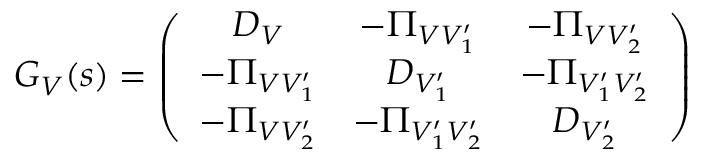Convert formula to latex. <formula><loc_0><loc_0><loc_500><loc_500>G _ { V } ( s ) = \left ( \begin{array} { c c c } { { D _ { V } } } & { { - \Pi _ { V V _ { 1 } ^ { \prime } } } } & { { - \Pi _ { V V _ { 2 } ^ { \prime } } } } \\ { { - \Pi _ { V V _ { 1 } ^ { \prime } } } } & { { D _ { V _ { 1 } ^ { \prime } } } } & { { - \Pi _ { V _ { 1 } ^ { \prime } V _ { 2 } ^ { \prime } } } } \\ { { - \Pi _ { V V _ { 2 } ^ { \prime } } } } & { { - \Pi _ { V _ { 1 } ^ { \prime } V _ { 2 } ^ { \prime } } } } & { { D _ { V _ { 2 } ^ { \prime } } } } \end{array} \right ) \,</formula> 